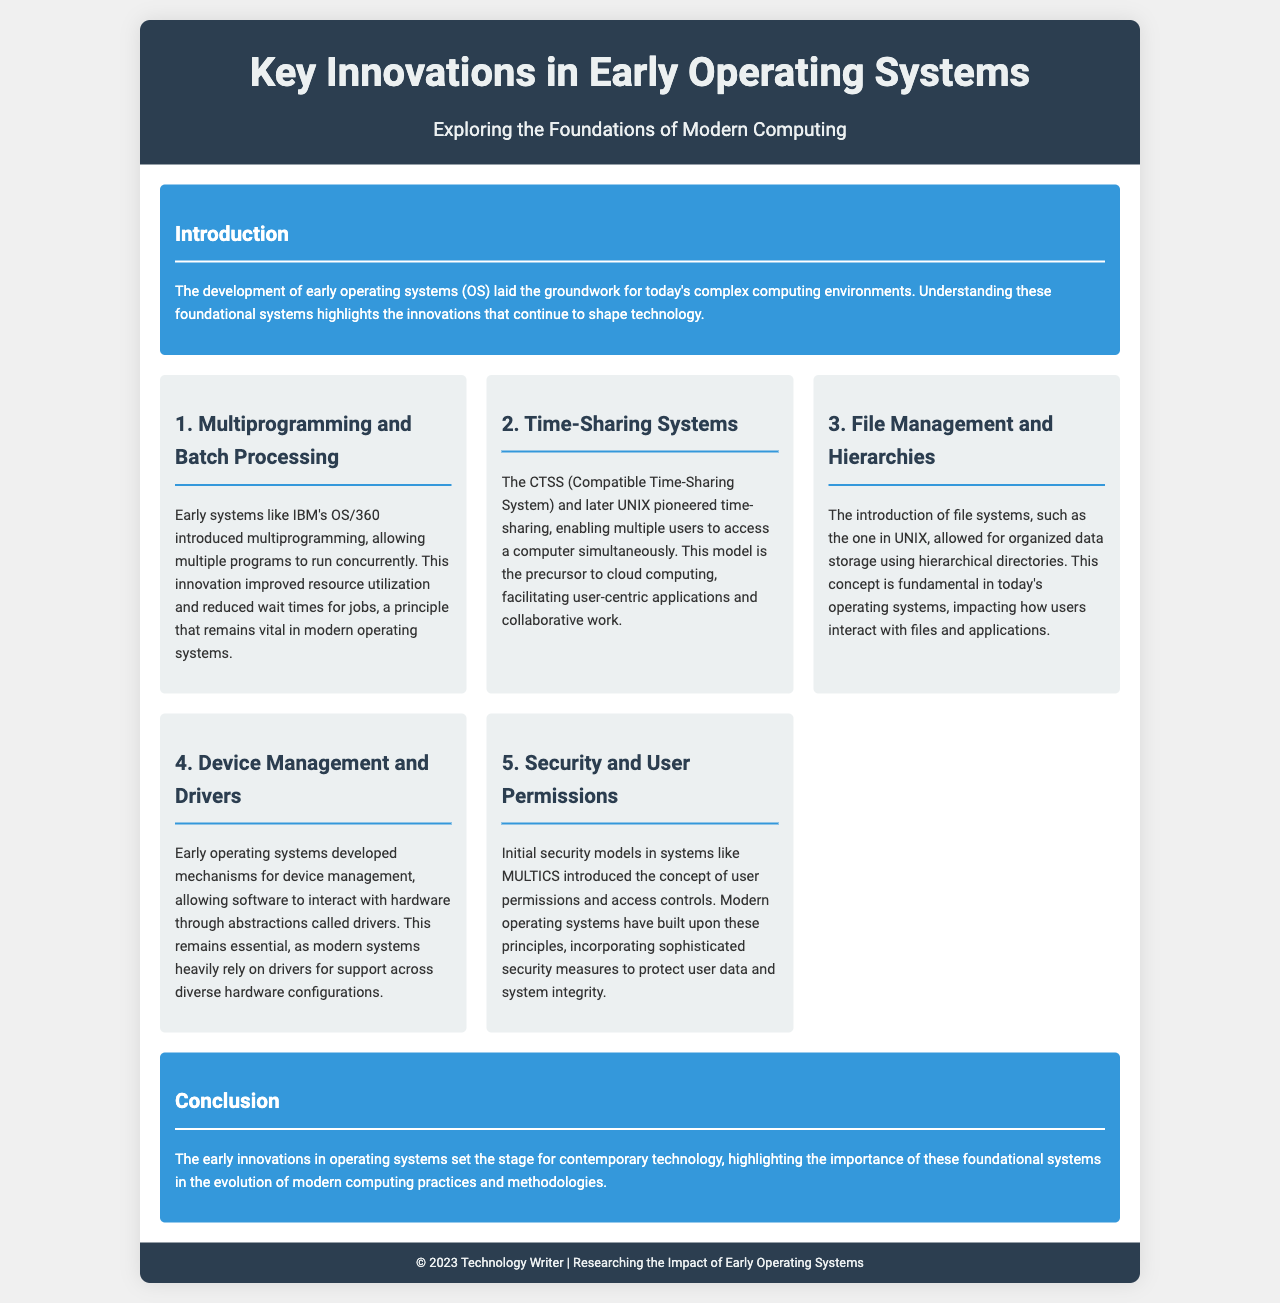What is the main topic of the brochure? The main topic is indicated in the title of the brochure, which focuses on key innovations in early operating systems.
Answer: Key Innovations in Early Operating Systems What did multiprogramming improve? The document mentions that multiprogramming improved resource utilization and reduced wait times for jobs.
Answer: Resource utilization Which system pioneered time-sharing? The brochure highlights that CTSS, or Compatible Time-Sharing System, pioneered time-sharing.
Answer: CTSS What does UNIX utilize for organized data storage? The brochure states that UNIX introduced a file system that organizes data using hierarchical directories.
Answer: Hierarchical directories What was introduced by the security models in MULTICS? The document explains that initial security models in MULTICS introduced user permissions and access controls.
Answer: User permissions and access controls How does the conclusion summarize the impact of early operating systems? The conclusion emphasizes that early innovations set the stage for contemporary technology, reflecting their significant influence.
Answer: Set the stage for contemporary technology What is the design style of the brochure? The style is visually designed to have a clean, modern, and professional appearance, using specific fonts and colors.
Answer: Clean, modern, professional In what year is the brochure published? The footer provides the publication year of the brochure as 2023.
Answer: 2023 What type of document is this? This document is specified in the title and throughout the layout as a brochure.
Answer: Brochure 